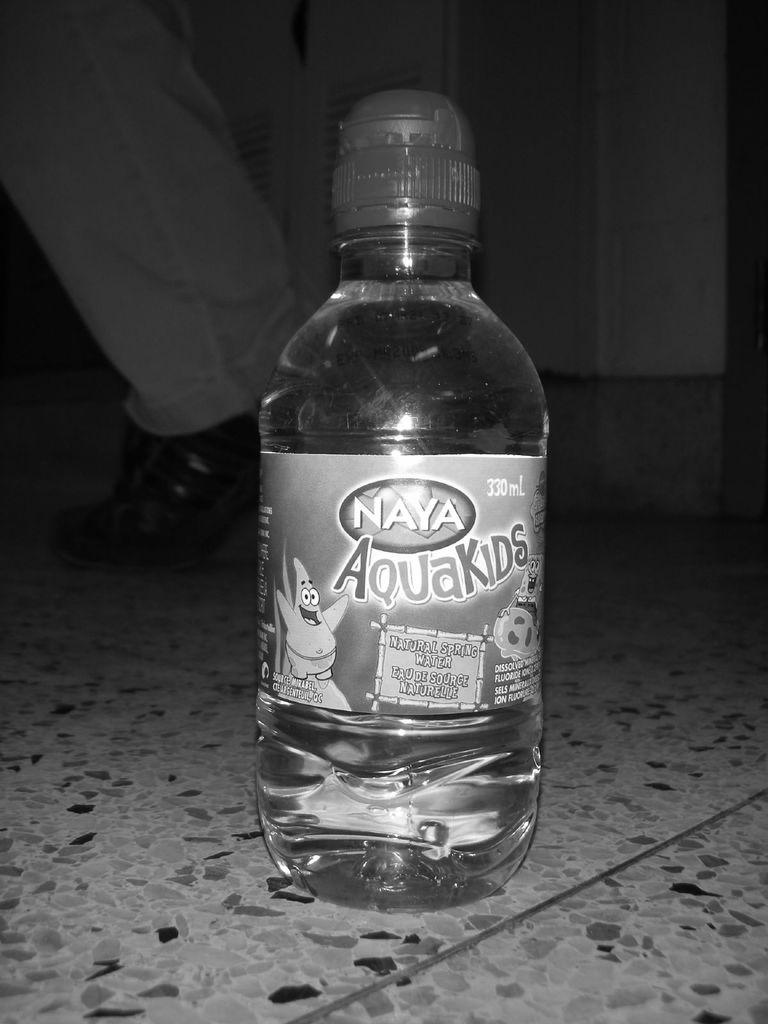<image>
Summarize the visual content of the image. Naya aquakids water bottle sitting on the floor 